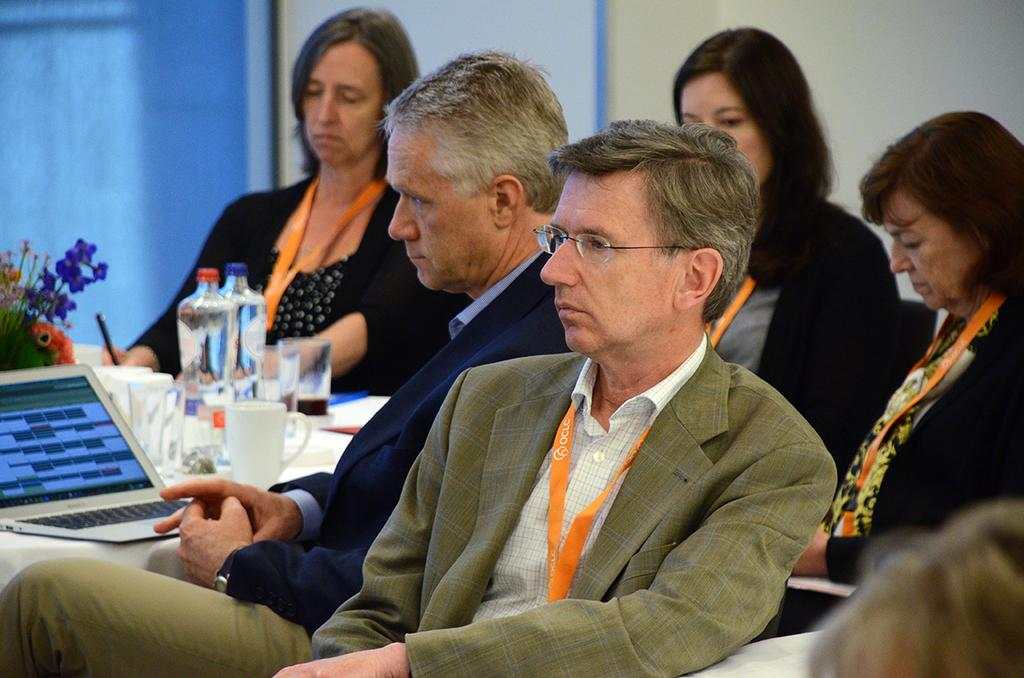How many people are in the image? There are persons in the image, but the exact number is not specified. What type of containers can be seen in the image? There are bottles in the image. What is used for holding flowers in the image? There is a flower vase in the image. What writing instrument is present in the image? There is a pen in the image. What electronic device is visible in the image? There is a laptop in the image. What type of eyewear is in the image? There are glasses in the image. What can be seen in the background of the image? There is a wall and an object in the background of the image. How many cars are parked in the background of the image? There are no cars visible in the image; only a wall and an object are present in the background. What type of vessel is used for sailing in the image? There is no vessel for sailing present in the image. 